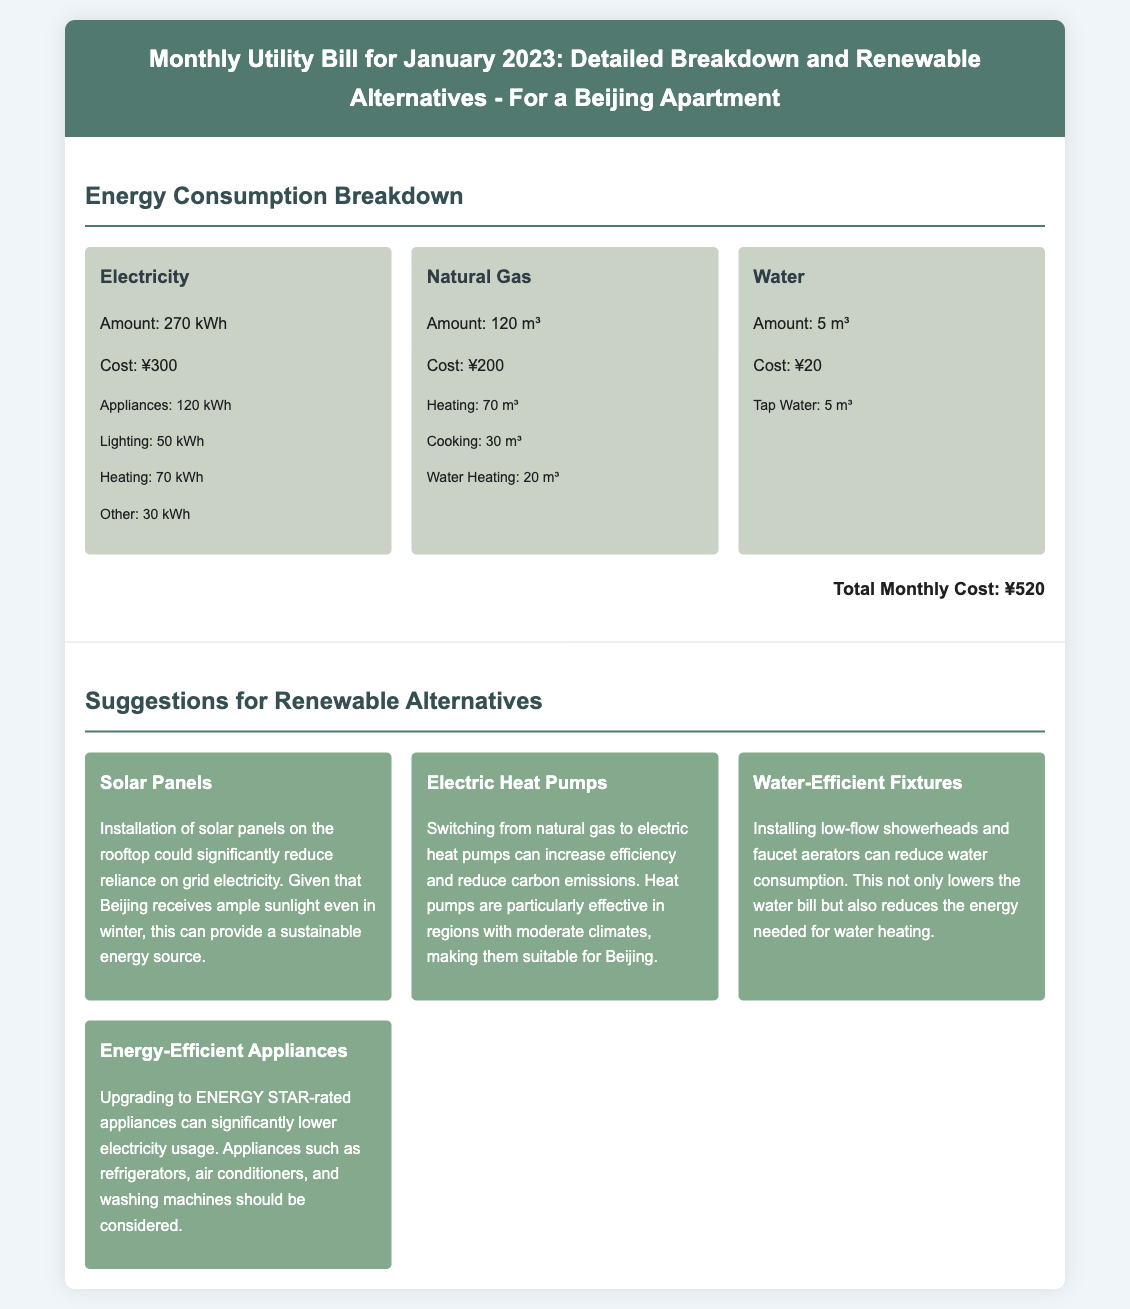What is the total cost for January 2023? The total monthly cost is provided at the end of the energy consumption breakdown section.
Answer: ¥520 How much electricity was consumed? The total amount of electricity consumption is listed in the energy consumption breakdown.
Answer: 270 kWh How many cubic meters of natural gas were used? This figure is stated in the natural gas consumption section of the document.
Answer: 120 m³ What renewable alternative suggests reducing reliance on grid electricity? This suggestion can be found in the section on renewable alternatives.
Answer: Solar Panels How much was spent on water consumption? This cost is specified in the water consumption section.
Answer: ¥20 Which alternative can decrease carbon emissions? This option is mentioned along with a description in the renewable suggestions section.
Answer: Electric Heat Pumps What was the natural gas consumption for cooking? Specific usage information for cooking is provided in the details under natural gas.
Answer: 30 m³ What energy-efficient appliance is mentioned for upgrading? This is listed in the renewable alternatives section discussing efficient appliances.
Answer: ENERGY STAR-rated appliances How much natural gas was used for heating? This specific detail can be found in the natural gas consumption breakdown.
Answer: 70 m³ 